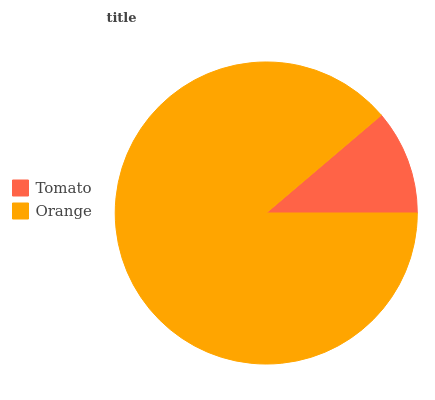Is Tomato the minimum?
Answer yes or no. Yes. Is Orange the maximum?
Answer yes or no. Yes. Is Orange the minimum?
Answer yes or no. No. Is Orange greater than Tomato?
Answer yes or no. Yes. Is Tomato less than Orange?
Answer yes or no. Yes. Is Tomato greater than Orange?
Answer yes or no. No. Is Orange less than Tomato?
Answer yes or no. No. Is Orange the high median?
Answer yes or no. Yes. Is Tomato the low median?
Answer yes or no. Yes. Is Tomato the high median?
Answer yes or no. No. Is Orange the low median?
Answer yes or no. No. 